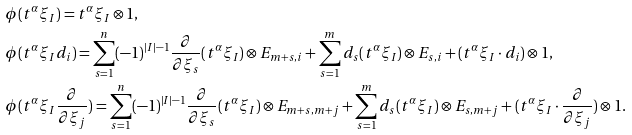Convert formula to latex. <formula><loc_0><loc_0><loc_500><loc_500>& \phi ( t ^ { \alpha } \xi _ { I } ) = t ^ { \alpha } \xi _ { I } \otimes 1 , \\ & \phi ( t ^ { \alpha } \xi _ { I } d _ { i } ) = \sum _ { s = 1 } ^ { n } ( - 1 ) ^ { | I | - 1 } \frac { \partial } { \partial \xi _ { s } } ( t ^ { \alpha } \xi _ { I } ) \otimes E _ { m + s , i } + \sum _ { s = 1 } ^ { m } d _ { s } ( t ^ { \alpha } \xi _ { I } ) \otimes E _ { s , i } + ( t ^ { \alpha } \xi _ { I } \cdot d _ { i } ) \otimes 1 , \\ & \phi ( t ^ { \alpha } \xi _ { I } \frac { \partial } { \partial \xi _ { j } } ) = \sum _ { s = 1 } ^ { n } ( - 1 ) ^ { | I | - 1 } \frac { \partial } { \partial \xi _ { s } } ( t ^ { \alpha } \xi _ { I } ) \otimes E _ { m + s , m + j } + \sum _ { s = 1 } ^ { m } d _ { s } ( t ^ { \alpha } \xi _ { I } ) \otimes E _ { s , m + j } + ( t ^ { \alpha } \xi _ { I } \cdot \frac { \partial } { \partial \xi _ { j } } ) \otimes 1 .</formula> 